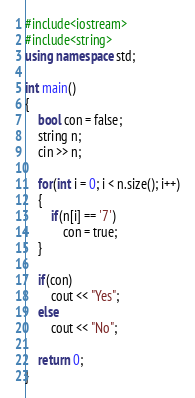Convert code to text. <code><loc_0><loc_0><loc_500><loc_500><_C++_>#include<iostream>
#include<string>
using namespace std;

int main()
{
    bool con = false;
    string n;
    cin >> n;

    for(int i = 0; i < n.size(); i++)
    {
        if(n[i] == '7')
            con = true;
    }

    if(con)
        cout << "Yes";
    else
        cout << "No";

    return 0;
}
</code> 